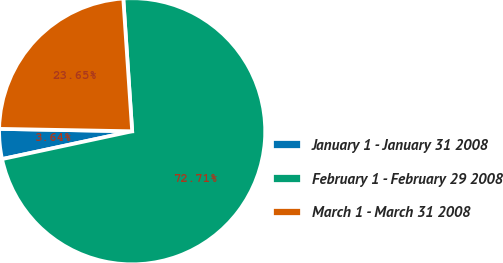<chart> <loc_0><loc_0><loc_500><loc_500><pie_chart><fcel>January 1 - January 31 2008<fcel>February 1 - February 29 2008<fcel>March 1 - March 31 2008<nl><fcel>3.64%<fcel>72.72%<fcel>23.65%<nl></chart> 